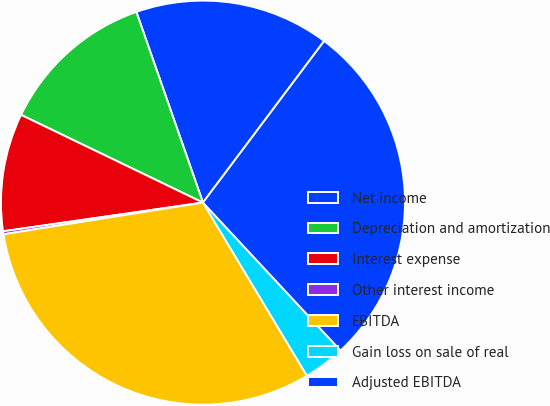Convert chart. <chart><loc_0><loc_0><loc_500><loc_500><pie_chart><fcel>Net income<fcel>Depreciation and amortization<fcel>Interest expense<fcel>Other interest income<fcel>EBITDA<fcel>Gain loss on sale of real<fcel>Adjusted EBITDA<nl><fcel>15.59%<fcel>12.5%<fcel>9.42%<fcel>0.24%<fcel>31.1%<fcel>3.32%<fcel>27.83%<nl></chart> 